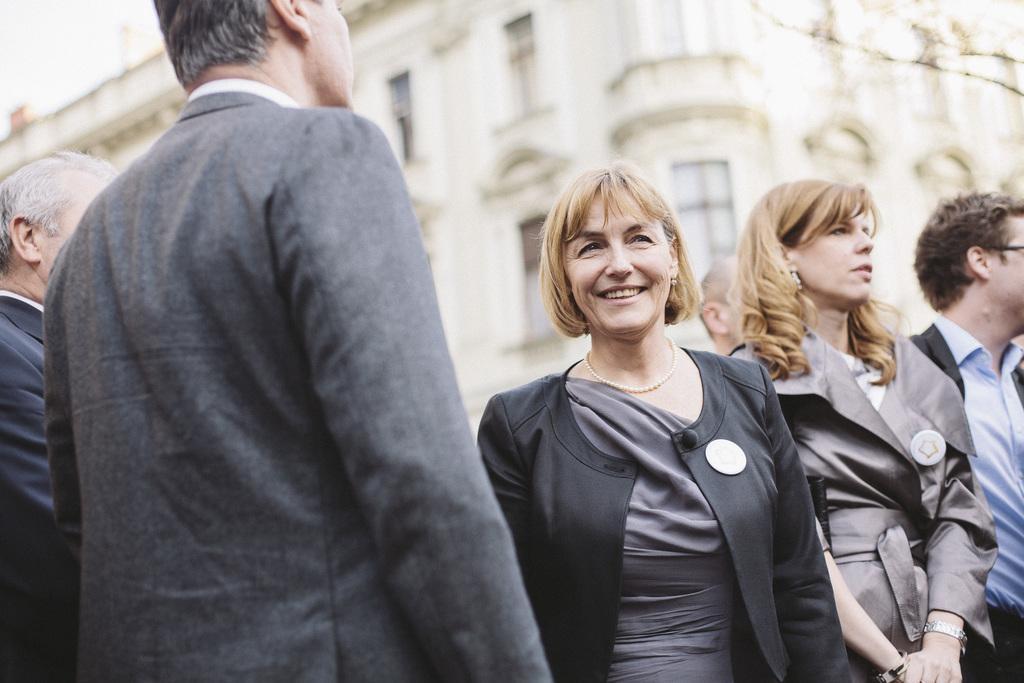Describe this image in one or two sentences. In the center of the image we can see persons standing on the road. In the background there is building. 